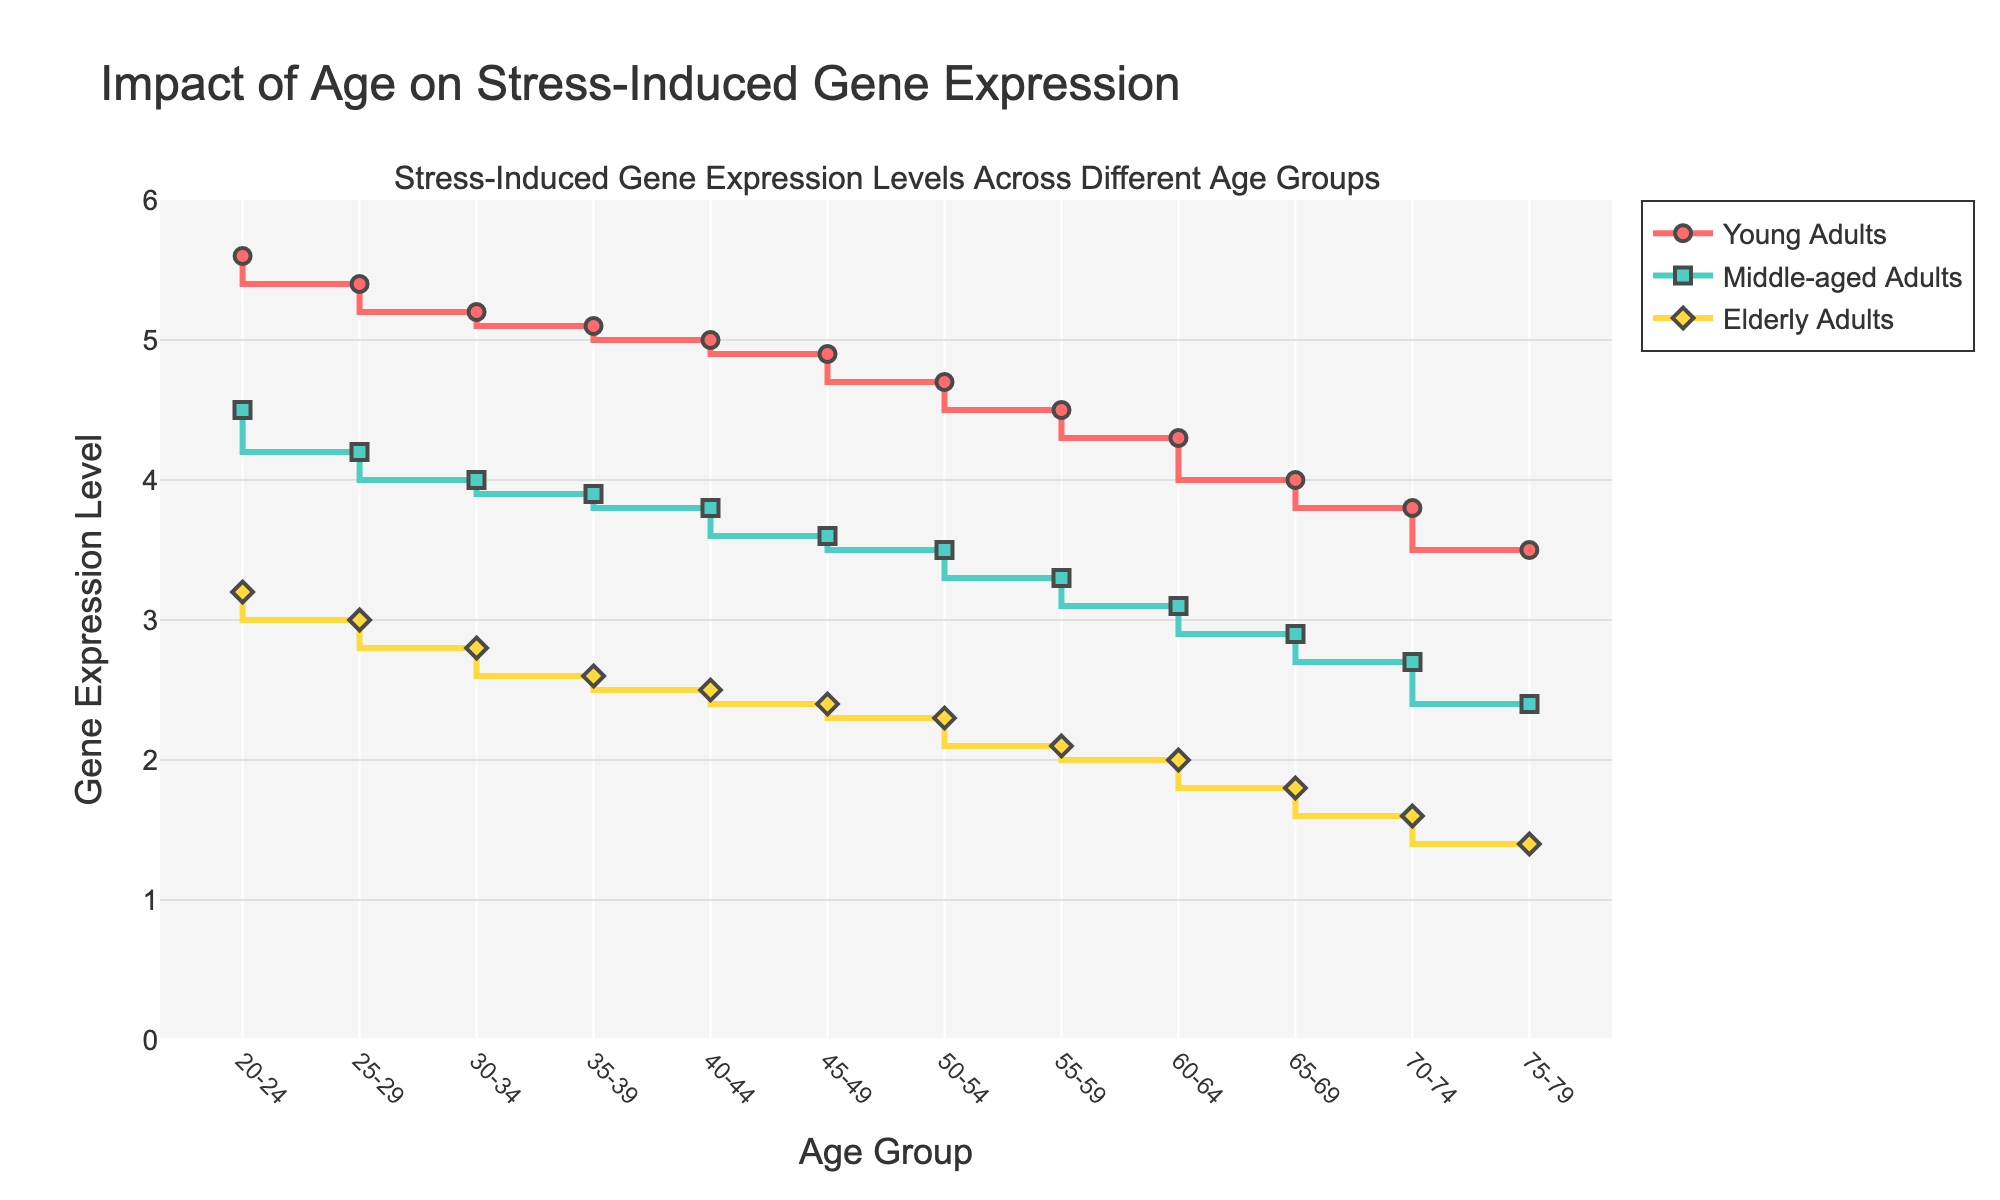What is the title of the figure? The title is displayed at the top of the figure in a prominent size. It reads "Impact of Age on Stress-Induced Gene Expression," clearly indicating what the figure represents.
Answer: Impact of Age on Stress-Induced Gene Expression Which age group exhibits the highest gene expression level in young adults? The figure shows gene expression levels for young adults across various age groups. The highest value appears at the 20-24 age group, represented by the highest point on the red line.
Answer: 20-24 By how much does the gene expression level decrease from the 20-24 to the 75-79 age group in young adults? To find the decrease, subtract the gene expression level at 75-79 from the level at 20-24. 5.6 (20-24) - 3.5 (75-79) = 2.1.
Answer: 2.1 Which age group shows the greatest difference in gene expression levels between young adults and elderly adults? To find the greatest difference, subtract the elderly gene expression levels from the young adults' levels across all age groups. The greatest difference is seen at 20-24: 5.6 (Young) - 3.2 (Elderly) = 2.4.
Answer: 20-24 Do middle-aged adults or elderly adults have a greater gene expression level throughout the age groups? By visually comparing the two lines, the middle-aged adults (green line) consistently show higher gene expression levels than the elderly adults (yellow line) across all age groups.
Answer: Middle-aged adults What is the overall trend in gene expression across age groups for young adults? Observing the red line for young adults, it starts high at 20-24 and gradually decreases with increasing age, indicating a downward trend in gene expression.
Answer: Downward At which age group do middle-aged adults and elderly adults exhibit the same gene expression level? By looking at the intersection points of the green and yellow lines, you can see that the gene expression levels are the same at no point, meaning there is no overlap between these two age groups.
Answer: None What is the average gene expression level for middle-aged adults across all age groups? To find the average, sum all gene expression levels for middle-aged adults and divide by the number of age groups. (4.5 + 4.2 + 4.0 + 3.9 + 3.8 + 3.6 + 3.5 + 3.3 + 3.1 + 2.9 + 2.7 + 2.4) / 12 = 3.6.
Answer: 3.6 Which group shows the largest decrease in gene expression from the youngest to the oldest age group? Calculate the decrease for each group: Young Adults: 5.6 - 3.5 = 2.1, Middle-aged Adults: 4.5 - 2.4 = 2.1, Elderly Adults: 3.2 - 1.4 = 1.8. Young Adults and Middle-aged Adults both show the largest decrease of 2.1.
Answer: Young Adults and Middle-aged Adults 